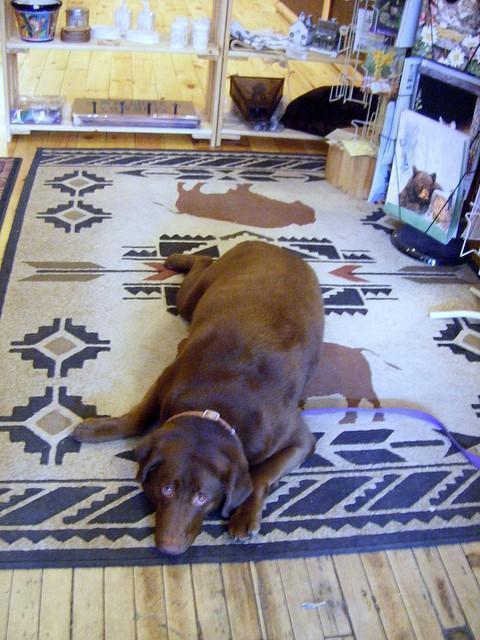What kind of dog is laying on the carpet?
From the following set of four choices, select the accurate answer to respond to the question.
Options: Brown lab, terrier, pug, poodle. Brown lab. 